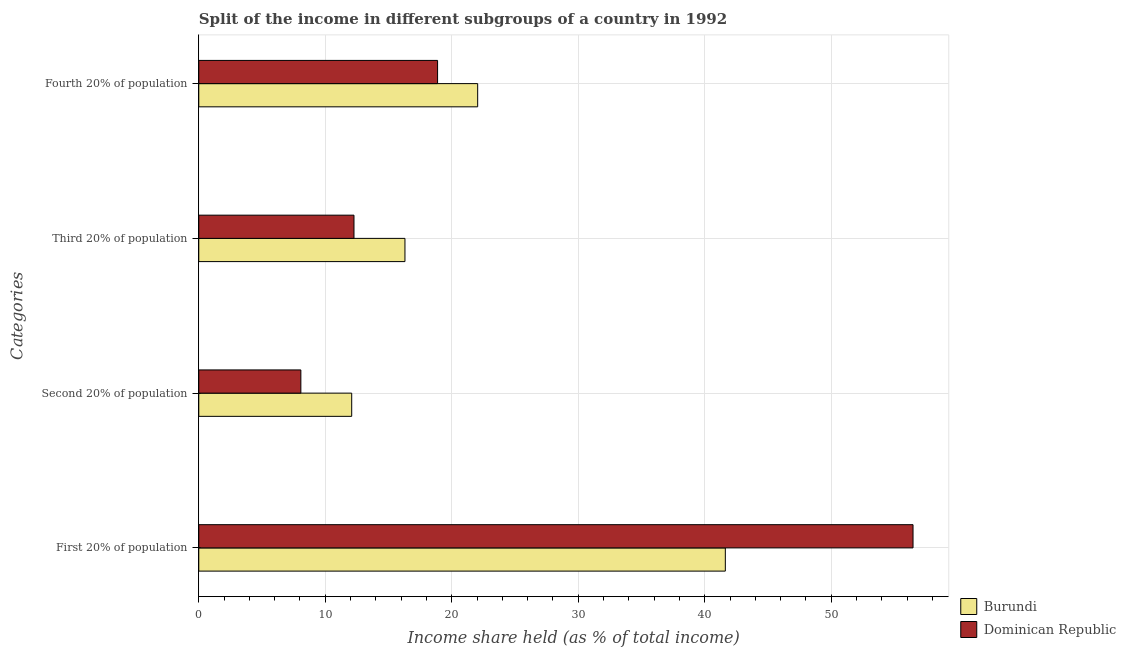How many groups of bars are there?
Offer a terse response. 4. Are the number of bars on each tick of the Y-axis equal?
Your answer should be very brief. Yes. What is the label of the 2nd group of bars from the top?
Keep it short and to the point. Third 20% of population. What is the share of the income held by third 20% of the population in Dominican Republic?
Your response must be concise. 12.27. Across all countries, what is the maximum share of the income held by second 20% of the population?
Keep it short and to the point. 12.09. Across all countries, what is the minimum share of the income held by first 20% of the population?
Provide a succinct answer. 41.63. In which country was the share of the income held by fourth 20% of the population maximum?
Make the answer very short. Burundi. In which country was the share of the income held by first 20% of the population minimum?
Provide a succinct answer. Burundi. What is the total share of the income held by third 20% of the population in the graph?
Offer a very short reply. 28.57. What is the difference between the share of the income held by second 20% of the population in Dominican Republic and that in Burundi?
Your answer should be very brief. -4.02. What is the difference between the share of the income held by third 20% of the population in Dominican Republic and the share of the income held by second 20% of the population in Burundi?
Provide a short and direct response. 0.18. What is the average share of the income held by second 20% of the population per country?
Keep it short and to the point. 10.08. What is the difference between the share of the income held by first 20% of the population and share of the income held by third 20% of the population in Burundi?
Offer a very short reply. 25.33. What is the ratio of the share of the income held by fourth 20% of the population in Burundi to that in Dominican Republic?
Provide a short and direct response. 1.17. Is the share of the income held by first 20% of the population in Dominican Republic less than that in Burundi?
Keep it short and to the point. No. Is the difference between the share of the income held by third 20% of the population in Dominican Republic and Burundi greater than the difference between the share of the income held by fourth 20% of the population in Dominican Republic and Burundi?
Provide a succinct answer. No. What is the difference between the highest and the second highest share of the income held by first 20% of the population?
Ensure brevity in your answer.  14.84. What is the difference between the highest and the lowest share of the income held by third 20% of the population?
Your response must be concise. 4.03. In how many countries, is the share of the income held by fourth 20% of the population greater than the average share of the income held by fourth 20% of the population taken over all countries?
Provide a short and direct response. 1. Is it the case that in every country, the sum of the share of the income held by third 20% of the population and share of the income held by second 20% of the population is greater than the sum of share of the income held by first 20% of the population and share of the income held by fourth 20% of the population?
Offer a terse response. No. What does the 2nd bar from the top in Second 20% of population represents?
Offer a terse response. Burundi. What does the 2nd bar from the bottom in Fourth 20% of population represents?
Offer a terse response. Dominican Republic. How many countries are there in the graph?
Give a very brief answer. 2. Are the values on the major ticks of X-axis written in scientific E-notation?
Provide a short and direct response. No. Does the graph contain any zero values?
Provide a short and direct response. No. How many legend labels are there?
Make the answer very short. 2. What is the title of the graph?
Offer a very short reply. Split of the income in different subgroups of a country in 1992. Does "Sweden" appear as one of the legend labels in the graph?
Give a very brief answer. No. What is the label or title of the X-axis?
Keep it short and to the point. Income share held (as % of total income). What is the label or title of the Y-axis?
Your response must be concise. Categories. What is the Income share held (as % of total income) in Burundi in First 20% of population?
Offer a terse response. 41.63. What is the Income share held (as % of total income) of Dominican Republic in First 20% of population?
Ensure brevity in your answer.  56.47. What is the Income share held (as % of total income) in Burundi in Second 20% of population?
Offer a very short reply. 12.09. What is the Income share held (as % of total income) in Dominican Republic in Second 20% of population?
Offer a terse response. 8.07. What is the Income share held (as % of total income) in Dominican Republic in Third 20% of population?
Provide a short and direct response. 12.27. What is the Income share held (as % of total income) in Burundi in Fourth 20% of population?
Keep it short and to the point. 22.05. What is the Income share held (as % of total income) in Dominican Republic in Fourth 20% of population?
Give a very brief answer. 18.88. Across all Categories, what is the maximum Income share held (as % of total income) of Burundi?
Your response must be concise. 41.63. Across all Categories, what is the maximum Income share held (as % of total income) of Dominican Republic?
Your answer should be very brief. 56.47. Across all Categories, what is the minimum Income share held (as % of total income) of Burundi?
Keep it short and to the point. 12.09. Across all Categories, what is the minimum Income share held (as % of total income) in Dominican Republic?
Provide a succinct answer. 8.07. What is the total Income share held (as % of total income) in Burundi in the graph?
Give a very brief answer. 92.07. What is the total Income share held (as % of total income) of Dominican Republic in the graph?
Your answer should be very brief. 95.69. What is the difference between the Income share held (as % of total income) of Burundi in First 20% of population and that in Second 20% of population?
Your answer should be compact. 29.54. What is the difference between the Income share held (as % of total income) in Dominican Republic in First 20% of population and that in Second 20% of population?
Provide a succinct answer. 48.4. What is the difference between the Income share held (as % of total income) in Burundi in First 20% of population and that in Third 20% of population?
Ensure brevity in your answer.  25.33. What is the difference between the Income share held (as % of total income) of Dominican Republic in First 20% of population and that in Third 20% of population?
Your response must be concise. 44.2. What is the difference between the Income share held (as % of total income) of Burundi in First 20% of population and that in Fourth 20% of population?
Your answer should be very brief. 19.58. What is the difference between the Income share held (as % of total income) in Dominican Republic in First 20% of population and that in Fourth 20% of population?
Offer a terse response. 37.59. What is the difference between the Income share held (as % of total income) in Burundi in Second 20% of population and that in Third 20% of population?
Offer a very short reply. -4.21. What is the difference between the Income share held (as % of total income) in Burundi in Second 20% of population and that in Fourth 20% of population?
Your answer should be compact. -9.96. What is the difference between the Income share held (as % of total income) in Dominican Republic in Second 20% of population and that in Fourth 20% of population?
Keep it short and to the point. -10.81. What is the difference between the Income share held (as % of total income) in Burundi in Third 20% of population and that in Fourth 20% of population?
Ensure brevity in your answer.  -5.75. What is the difference between the Income share held (as % of total income) in Dominican Republic in Third 20% of population and that in Fourth 20% of population?
Offer a terse response. -6.61. What is the difference between the Income share held (as % of total income) in Burundi in First 20% of population and the Income share held (as % of total income) in Dominican Republic in Second 20% of population?
Give a very brief answer. 33.56. What is the difference between the Income share held (as % of total income) in Burundi in First 20% of population and the Income share held (as % of total income) in Dominican Republic in Third 20% of population?
Your answer should be very brief. 29.36. What is the difference between the Income share held (as % of total income) in Burundi in First 20% of population and the Income share held (as % of total income) in Dominican Republic in Fourth 20% of population?
Your answer should be compact. 22.75. What is the difference between the Income share held (as % of total income) of Burundi in Second 20% of population and the Income share held (as % of total income) of Dominican Republic in Third 20% of population?
Your response must be concise. -0.18. What is the difference between the Income share held (as % of total income) of Burundi in Second 20% of population and the Income share held (as % of total income) of Dominican Republic in Fourth 20% of population?
Your answer should be very brief. -6.79. What is the difference between the Income share held (as % of total income) of Burundi in Third 20% of population and the Income share held (as % of total income) of Dominican Republic in Fourth 20% of population?
Provide a succinct answer. -2.58. What is the average Income share held (as % of total income) of Burundi per Categories?
Provide a short and direct response. 23.02. What is the average Income share held (as % of total income) in Dominican Republic per Categories?
Provide a short and direct response. 23.92. What is the difference between the Income share held (as % of total income) of Burundi and Income share held (as % of total income) of Dominican Republic in First 20% of population?
Provide a succinct answer. -14.84. What is the difference between the Income share held (as % of total income) in Burundi and Income share held (as % of total income) in Dominican Republic in Second 20% of population?
Your answer should be very brief. 4.02. What is the difference between the Income share held (as % of total income) in Burundi and Income share held (as % of total income) in Dominican Republic in Third 20% of population?
Your response must be concise. 4.03. What is the difference between the Income share held (as % of total income) in Burundi and Income share held (as % of total income) in Dominican Republic in Fourth 20% of population?
Provide a short and direct response. 3.17. What is the ratio of the Income share held (as % of total income) of Burundi in First 20% of population to that in Second 20% of population?
Ensure brevity in your answer.  3.44. What is the ratio of the Income share held (as % of total income) of Dominican Republic in First 20% of population to that in Second 20% of population?
Your answer should be compact. 7. What is the ratio of the Income share held (as % of total income) of Burundi in First 20% of population to that in Third 20% of population?
Make the answer very short. 2.55. What is the ratio of the Income share held (as % of total income) in Dominican Republic in First 20% of population to that in Third 20% of population?
Ensure brevity in your answer.  4.6. What is the ratio of the Income share held (as % of total income) in Burundi in First 20% of population to that in Fourth 20% of population?
Keep it short and to the point. 1.89. What is the ratio of the Income share held (as % of total income) in Dominican Republic in First 20% of population to that in Fourth 20% of population?
Provide a short and direct response. 2.99. What is the ratio of the Income share held (as % of total income) of Burundi in Second 20% of population to that in Third 20% of population?
Provide a short and direct response. 0.74. What is the ratio of the Income share held (as % of total income) in Dominican Republic in Second 20% of population to that in Third 20% of population?
Provide a short and direct response. 0.66. What is the ratio of the Income share held (as % of total income) of Burundi in Second 20% of population to that in Fourth 20% of population?
Offer a very short reply. 0.55. What is the ratio of the Income share held (as % of total income) in Dominican Republic in Second 20% of population to that in Fourth 20% of population?
Provide a succinct answer. 0.43. What is the ratio of the Income share held (as % of total income) of Burundi in Third 20% of population to that in Fourth 20% of population?
Give a very brief answer. 0.74. What is the ratio of the Income share held (as % of total income) of Dominican Republic in Third 20% of population to that in Fourth 20% of population?
Make the answer very short. 0.65. What is the difference between the highest and the second highest Income share held (as % of total income) in Burundi?
Ensure brevity in your answer.  19.58. What is the difference between the highest and the second highest Income share held (as % of total income) of Dominican Republic?
Your response must be concise. 37.59. What is the difference between the highest and the lowest Income share held (as % of total income) in Burundi?
Offer a very short reply. 29.54. What is the difference between the highest and the lowest Income share held (as % of total income) of Dominican Republic?
Your answer should be compact. 48.4. 